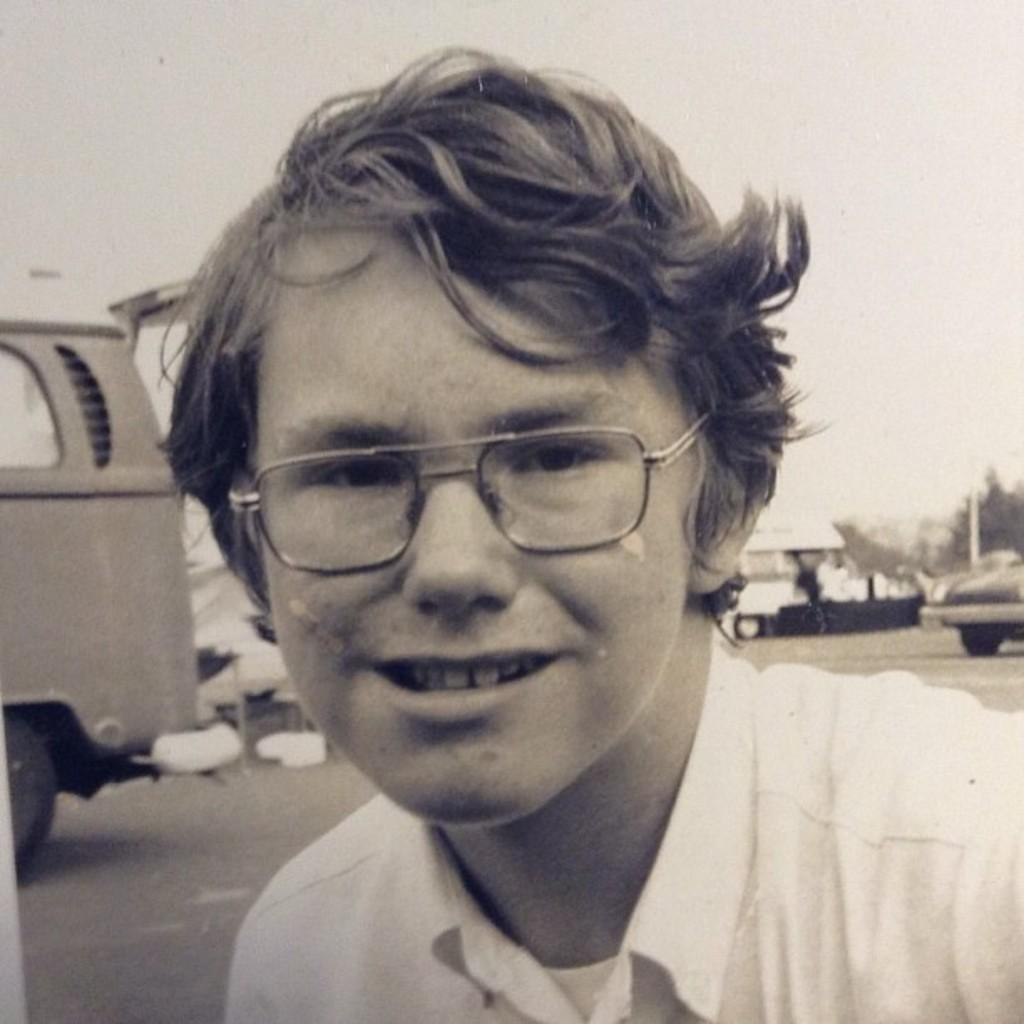What is the color scheme of the image? The image is black and white. Who or what is the main subject in the image? There is a person in the middle of the image. What accessory is the person wearing? The person is wearing glasses (specs). What can be seen behind the person in the image? There are vehicles visible behind the person. What type of ant can be seen crawling on the person's glasses in the image? There are no ants present in the image, and therefore no such activity can be observed. 